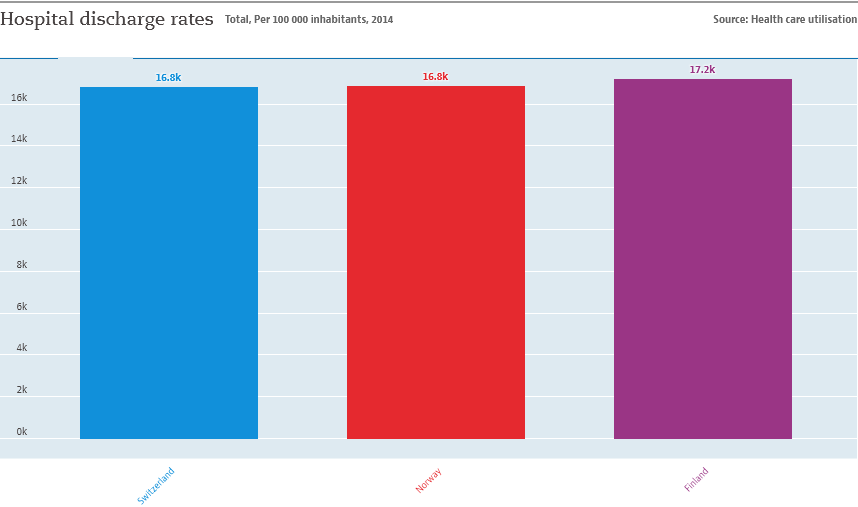Draw attention to some important aspects in this diagram. The average of all three data is 16.93. The red bar represents the country of Norway. 